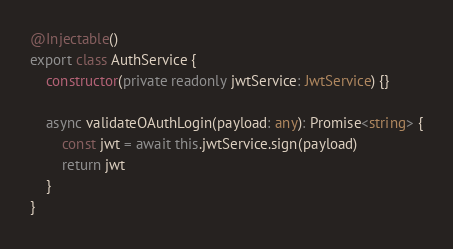<code> <loc_0><loc_0><loc_500><loc_500><_TypeScript_>
@Injectable()
export class AuthService {
    constructor(private readonly jwtService: JwtService) {}

    async validateOAuthLogin(payload: any): Promise<string> {
        const jwt = await this.jwtService.sign(payload)
        return jwt
    }
}
</code> 